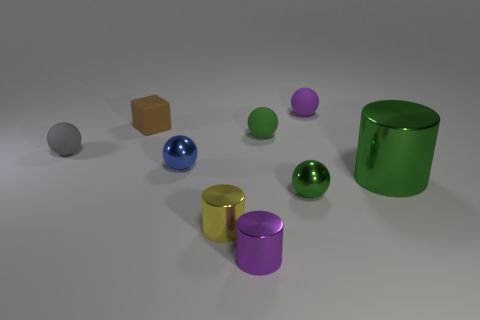Subtract all gray cylinders. How many green balls are left? 2 Subtract all green balls. How many balls are left? 3 Subtract 1 cylinders. How many cylinders are left? 2 Subtract all tiny purple rubber spheres. How many spheres are left? 4 Subtract all gray balls. Subtract all brown cylinders. How many balls are left? 4 Add 1 tiny brown cubes. How many objects exist? 10 Subtract all spheres. How many objects are left? 4 Subtract 1 yellow cylinders. How many objects are left? 8 Subtract all blue shiny things. Subtract all yellow matte spheres. How many objects are left? 8 Add 4 small brown rubber blocks. How many small brown rubber blocks are left? 5 